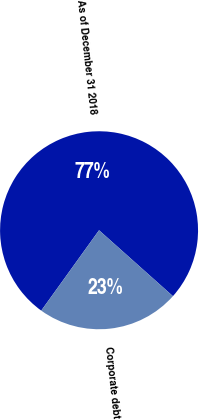Convert chart to OTSL. <chart><loc_0><loc_0><loc_500><loc_500><pie_chart><fcel>As of December 31 2018<fcel>Corporate debt<nl><fcel>76.67%<fcel>23.33%<nl></chart> 